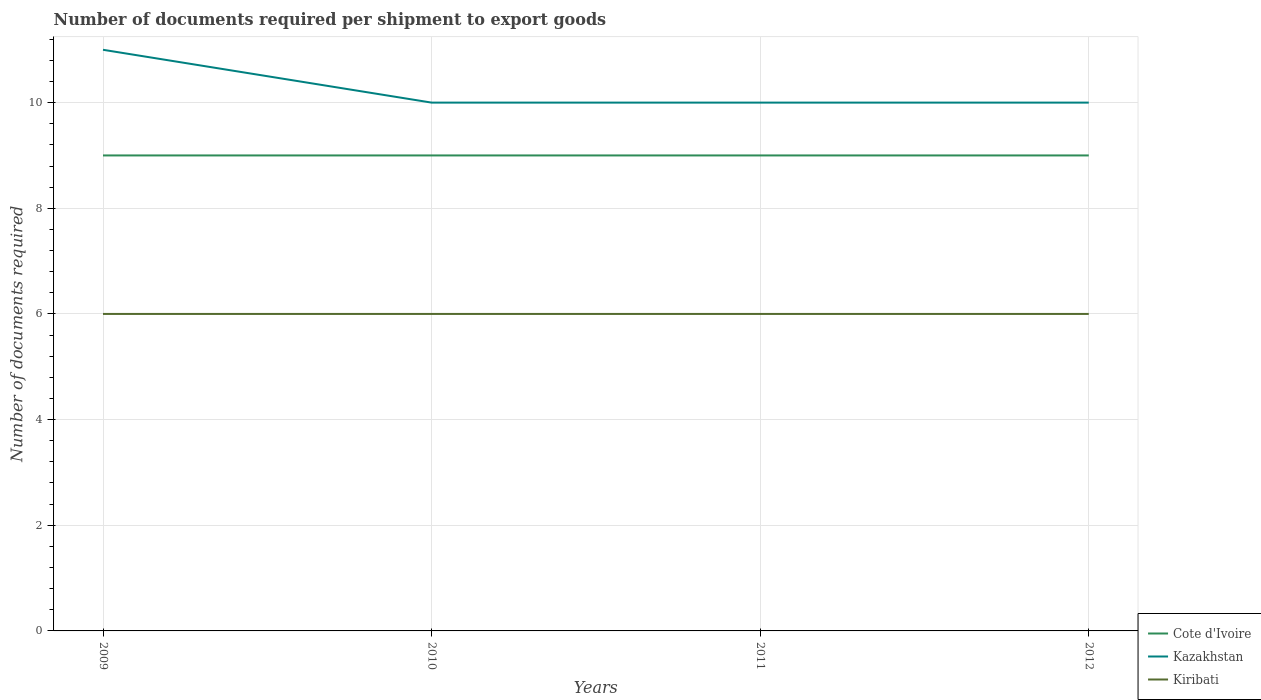How many different coloured lines are there?
Provide a succinct answer. 3. Across all years, what is the maximum number of documents required per shipment to export goods in Kazakhstan?
Your response must be concise. 10. In which year was the number of documents required per shipment to export goods in Kiribati maximum?
Offer a terse response. 2009. What is the total number of documents required per shipment to export goods in Kazakhstan in the graph?
Ensure brevity in your answer.  0. What is the difference between the highest and the lowest number of documents required per shipment to export goods in Cote d'Ivoire?
Make the answer very short. 0. Is the number of documents required per shipment to export goods in Cote d'Ivoire strictly greater than the number of documents required per shipment to export goods in Kazakhstan over the years?
Provide a short and direct response. Yes. How many lines are there?
Your response must be concise. 3. How many years are there in the graph?
Keep it short and to the point. 4. What is the difference between two consecutive major ticks on the Y-axis?
Your response must be concise. 2. Does the graph contain any zero values?
Provide a succinct answer. No. Where does the legend appear in the graph?
Offer a very short reply. Bottom right. How many legend labels are there?
Provide a short and direct response. 3. What is the title of the graph?
Your answer should be very brief. Number of documents required per shipment to export goods. Does "French Polynesia" appear as one of the legend labels in the graph?
Provide a succinct answer. No. What is the label or title of the Y-axis?
Your answer should be compact. Number of documents required. What is the Number of documents required of Kazakhstan in 2009?
Offer a terse response. 11. What is the Number of documents required of Kiribati in 2009?
Offer a very short reply. 6. What is the Number of documents required of Kiribati in 2010?
Make the answer very short. 6. What is the Number of documents required of Cote d'Ivoire in 2011?
Make the answer very short. 9. What is the Number of documents required in Kiribati in 2012?
Make the answer very short. 6. Across all years, what is the maximum Number of documents required in Kiribati?
Offer a terse response. 6. Across all years, what is the minimum Number of documents required in Cote d'Ivoire?
Provide a short and direct response. 9. What is the total Number of documents required in Cote d'Ivoire in the graph?
Make the answer very short. 36. What is the total Number of documents required of Kiribati in the graph?
Make the answer very short. 24. What is the difference between the Number of documents required of Kiribati in 2009 and that in 2010?
Make the answer very short. 0. What is the difference between the Number of documents required of Kiribati in 2009 and that in 2011?
Make the answer very short. 0. What is the difference between the Number of documents required in Cote d'Ivoire in 2009 and that in 2012?
Your answer should be compact. 0. What is the difference between the Number of documents required in Cote d'Ivoire in 2010 and that in 2012?
Provide a succinct answer. 0. What is the difference between the Number of documents required in Kazakhstan in 2010 and that in 2012?
Provide a succinct answer. 0. What is the difference between the Number of documents required of Kiribati in 2011 and that in 2012?
Provide a succinct answer. 0. What is the difference between the Number of documents required in Cote d'Ivoire in 2009 and the Number of documents required in Kiribati in 2010?
Ensure brevity in your answer.  3. What is the difference between the Number of documents required in Cote d'Ivoire in 2009 and the Number of documents required in Kazakhstan in 2011?
Ensure brevity in your answer.  -1. What is the difference between the Number of documents required of Cote d'Ivoire in 2010 and the Number of documents required of Kazakhstan in 2011?
Provide a succinct answer. -1. What is the difference between the Number of documents required in Cote d'Ivoire in 2010 and the Number of documents required in Kiribati in 2012?
Provide a short and direct response. 3. What is the difference between the Number of documents required in Kazakhstan in 2010 and the Number of documents required in Kiribati in 2012?
Offer a very short reply. 4. What is the difference between the Number of documents required of Kazakhstan in 2011 and the Number of documents required of Kiribati in 2012?
Make the answer very short. 4. What is the average Number of documents required in Cote d'Ivoire per year?
Provide a succinct answer. 9. What is the average Number of documents required in Kazakhstan per year?
Give a very brief answer. 10.25. What is the average Number of documents required of Kiribati per year?
Provide a short and direct response. 6. In the year 2009, what is the difference between the Number of documents required in Cote d'Ivoire and Number of documents required in Kazakhstan?
Make the answer very short. -2. In the year 2009, what is the difference between the Number of documents required of Cote d'Ivoire and Number of documents required of Kiribati?
Make the answer very short. 3. In the year 2010, what is the difference between the Number of documents required of Cote d'Ivoire and Number of documents required of Kiribati?
Offer a terse response. 3. In the year 2010, what is the difference between the Number of documents required in Kazakhstan and Number of documents required in Kiribati?
Provide a succinct answer. 4. In the year 2011, what is the difference between the Number of documents required of Cote d'Ivoire and Number of documents required of Kazakhstan?
Offer a terse response. -1. What is the ratio of the Number of documents required in Kiribati in 2009 to that in 2010?
Offer a very short reply. 1. What is the ratio of the Number of documents required in Cote d'Ivoire in 2009 to that in 2011?
Keep it short and to the point. 1. What is the ratio of the Number of documents required in Kazakhstan in 2009 to that in 2011?
Ensure brevity in your answer.  1.1. What is the ratio of the Number of documents required of Kiribati in 2009 to that in 2011?
Offer a very short reply. 1. What is the ratio of the Number of documents required of Cote d'Ivoire in 2009 to that in 2012?
Give a very brief answer. 1. What is the ratio of the Number of documents required in Kazakhstan in 2009 to that in 2012?
Your response must be concise. 1.1. What is the ratio of the Number of documents required in Kiribati in 2009 to that in 2012?
Provide a short and direct response. 1. What is the ratio of the Number of documents required in Kiribati in 2010 to that in 2011?
Offer a very short reply. 1. What is the ratio of the Number of documents required of Kazakhstan in 2010 to that in 2012?
Ensure brevity in your answer.  1. What is the ratio of the Number of documents required of Cote d'Ivoire in 2011 to that in 2012?
Your answer should be compact. 1. What is the ratio of the Number of documents required of Kiribati in 2011 to that in 2012?
Give a very brief answer. 1. What is the difference between the highest and the second highest Number of documents required of Cote d'Ivoire?
Your answer should be very brief. 0. What is the difference between the highest and the lowest Number of documents required of Kazakhstan?
Give a very brief answer. 1. What is the difference between the highest and the lowest Number of documents required of Kiribati?
Provide a short and direct response. 0. 